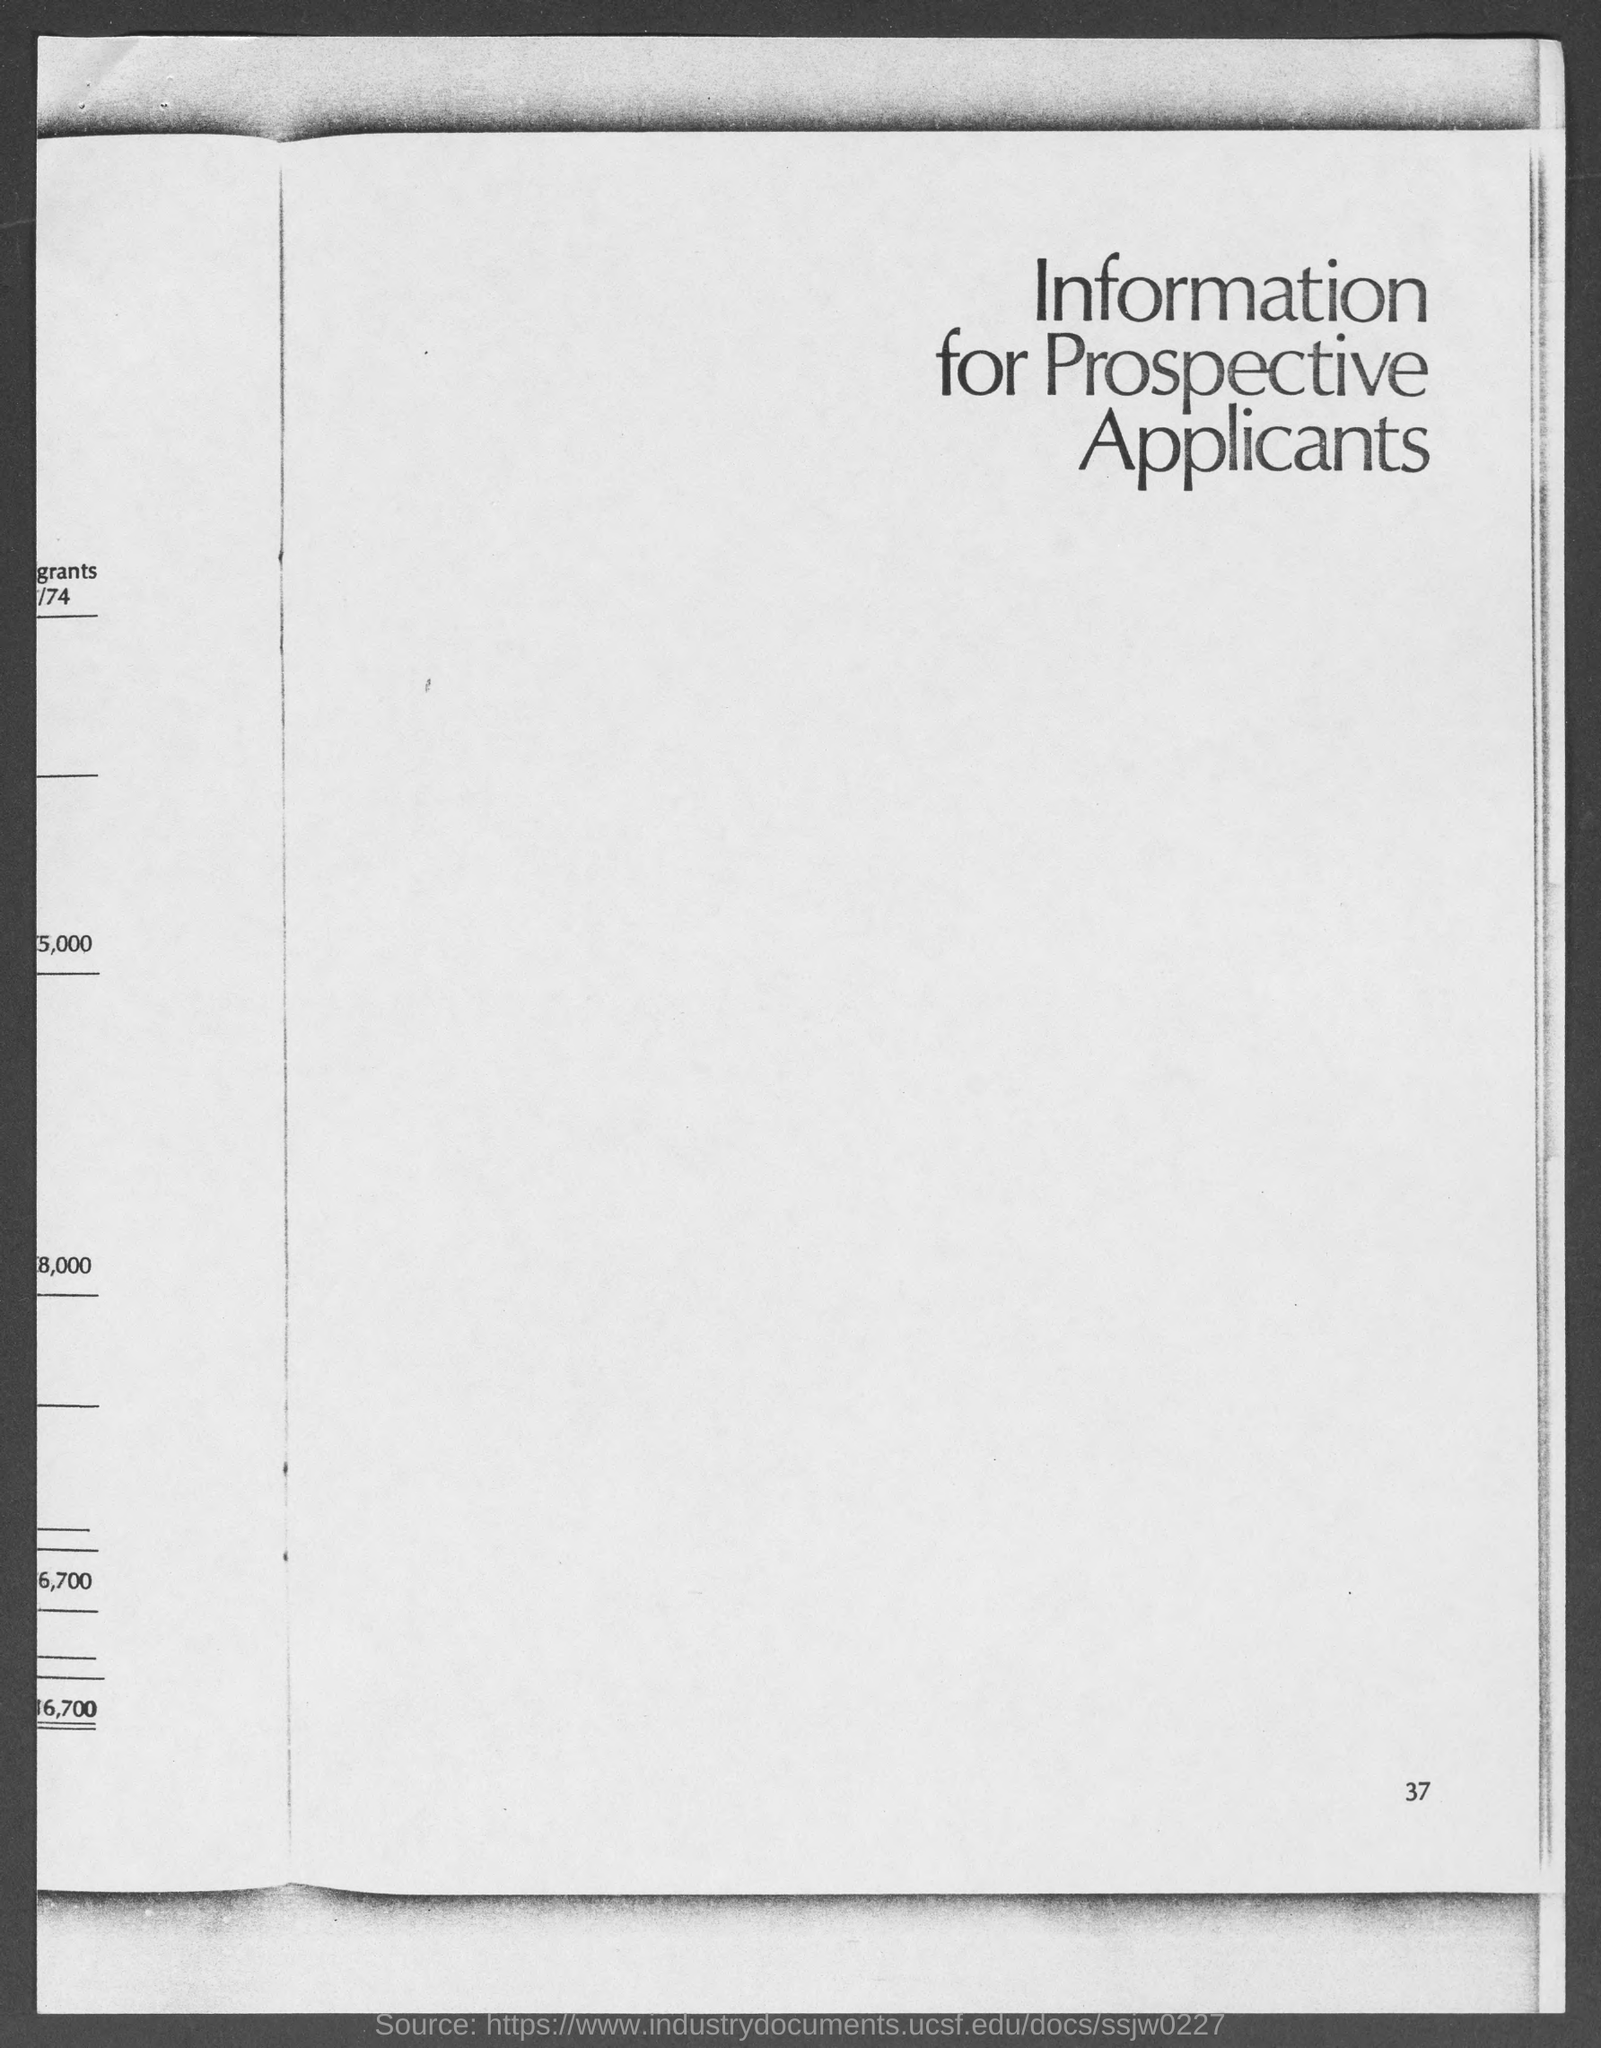List a handful of essential elements in this visual. The information is for prospective applicants. The page number at the bottom of the page is 37. 